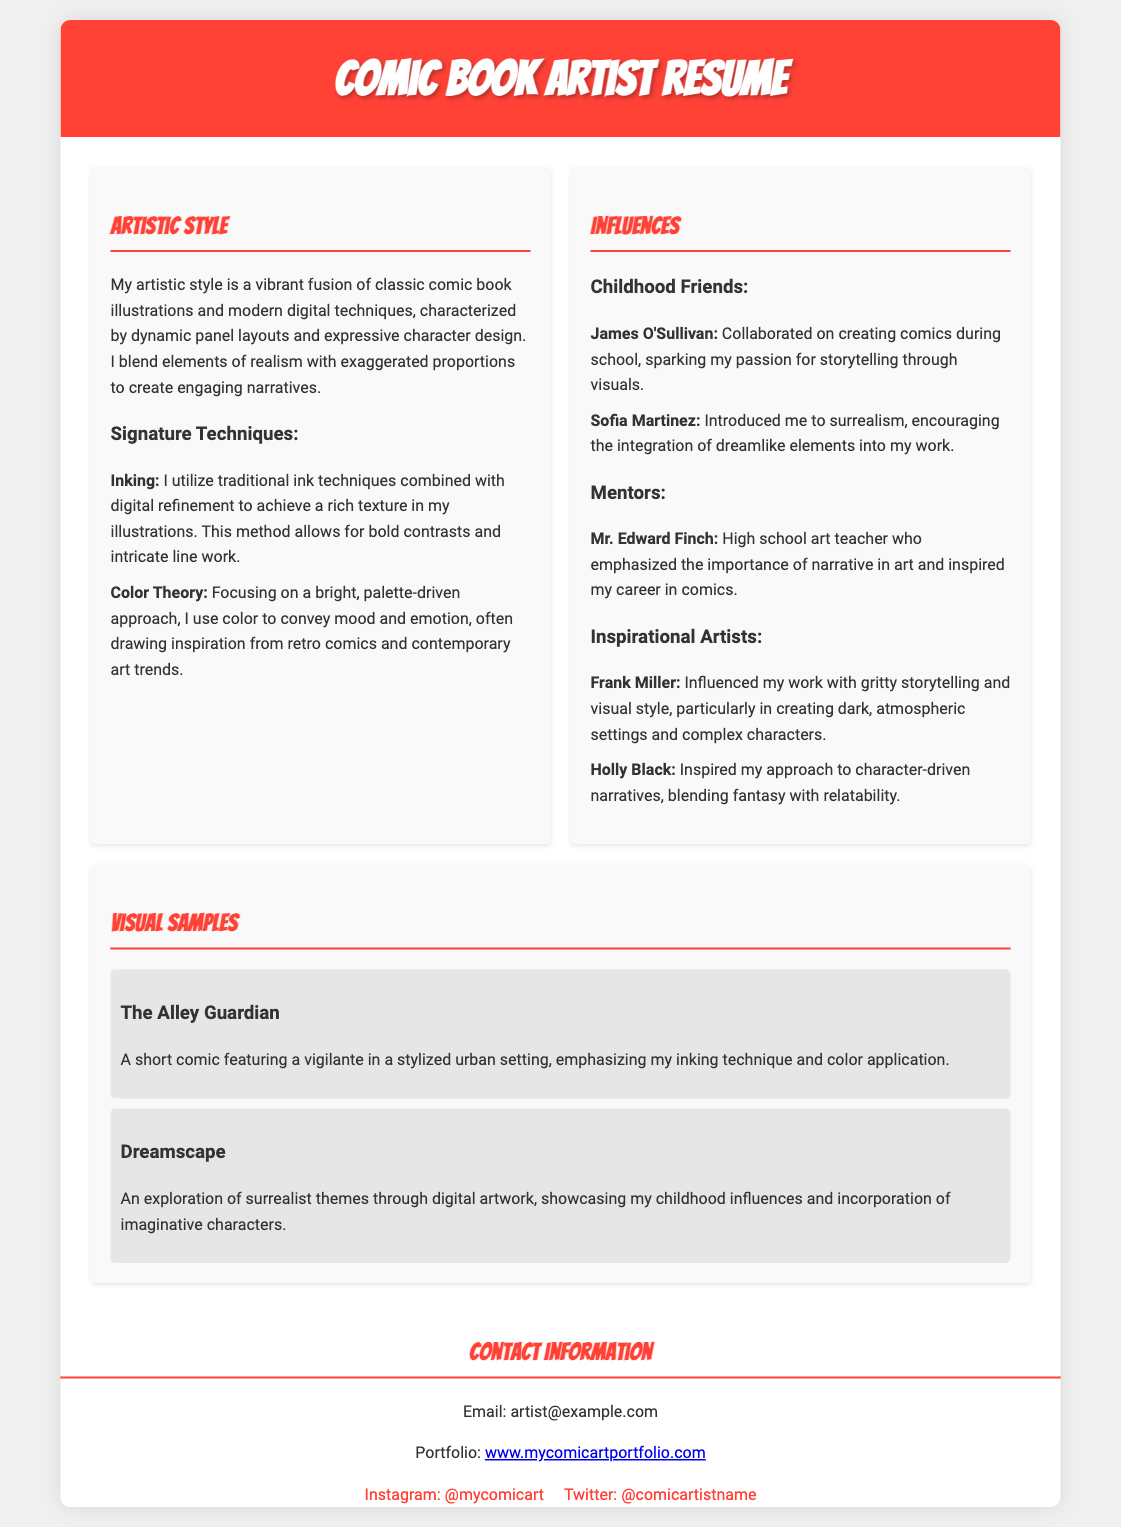what is the artistic style described in the resume? The artistic style is a vibrant fusion of classic comic book illustrations and modern digital techniques.
Answer: vibrant fusion of classic comic book illustrations and modern digital techniques who is one of the childhood friends mentioned as an influence? The resume lists James O'Sullivan as one of the childhood friends who influenced the artist.
Answer: James O'Sullivan what signature technique focuses on color to convey mood and emotion? The technique mentioned is Color Theory, which focuses on using color to convey mood and emotion.
Answer: Color Theory which inspirational artist is known for gritty storytelling? Frank Miller is noted for his influence with gritty storytelling and visual style.
Answer: Frank Miller how many visual samples are showcased in the document? There are two visual samples described in the resume.
Answer: two what is the title of the comic featuring a vigilante? The title of the comic featuring a vigilante is "The Alley Guardian."
Answer: The Alley Guardian who motivated the artist's narrative approach in art? Mr. Edward Finch, the high school art teacher, motivated the artist's narrative approach in art.
Answer: Mr. Edward Finch what is the primary contact method listed in the document? The primary contact method listed is via email.
Answer: email what element is emphasized in "Dreamscape"? "Dreamscape" emphasizes surrealist themes through digital artwork.
Answer: surrealist themes 